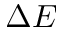<formula> <loc_0><loc_0><loc_500><loc_500>\Delta E</formula> 